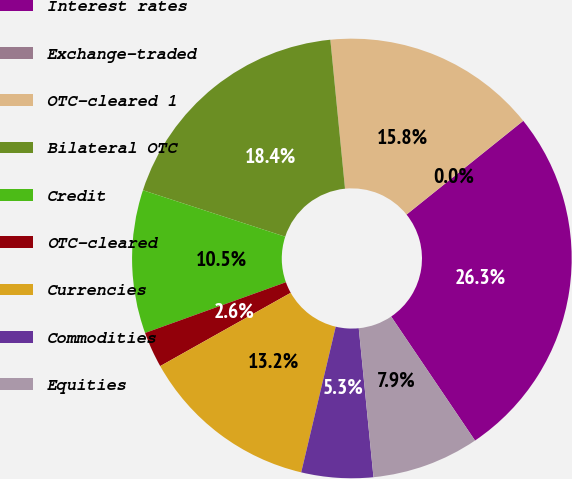<chart> <loc_0><loc_0><loc_500><loc_500><pie_chart><fcel>Interest rates<fcel>Exchange-traded<fcel>OTC-cleared 1<fcel>Bilateral OTC<fcel>Credit<fcel>OTC-cleared<fcel>Currencies<fcel>Commodities<fcel>Equities<nl><fcel>26.31%<fcel>0.01%<fcel>15.79%<fcel>18.42%<fcel>10.53%<fcel>2.64%<fcel>13.16%<fcel>5.27%<fcel>7.9%<nl></chart> 